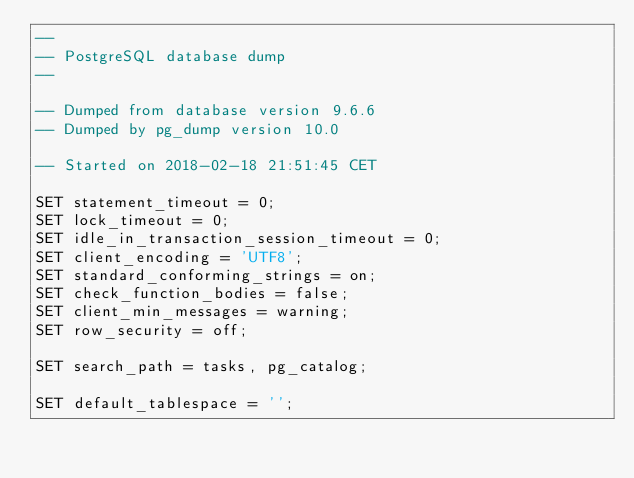<code> <loc_0><loc_0><loc_500><loc_500><_SQL_>--
-- PostgreSQL database dump
--

-- Dumped from database version 9.6.6
-- Dumped by pg_dump version 10.0

-- Started on 2018-02-18 21:51:45 CET

SET statement_timeout = 0;
SET lock_timeout = 0;
SET idle_in_transaction_session_timeout = 0;
SET client_encoding = 'UTF8';
SET standard_conforming_strings = on;
SET check_function_bodies = false;
SET client_min_messages = warning;
SET row_security = off;

SET search_path = tasks, pg_catalog;

SET default_tablespace = '';
</code> 